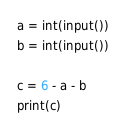Convert code to text. <code><loc_0><loc_0><loc_500><loc_500><_Python_>a = int(input())
b = int(input())

c = 6 - a - b
print(c)
</code> 